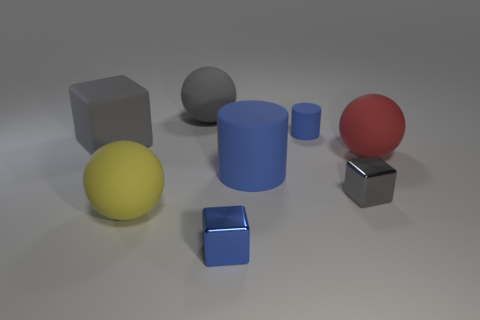Could you explain the lighting in this image? Certainly. The lighting in the image appears to be soft and diffuse, as indicated by the gentle shadows and slight gradient on the surface of the objects and the ground. There is no sign of harsh direct light, such as bright highlights or strong, crisp shadows. This suggests an indirect light source, commonly used in a studio setting, which provides a neutral environment to present the objects clearly. 